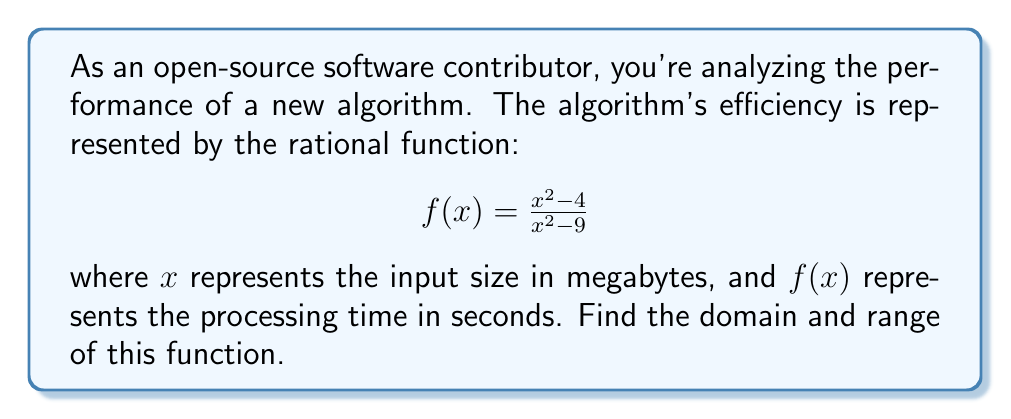Provide a solution to this math problem. To find the domain and range of this rational function, we'll follow these steps:

1. Domain:
   The domain consists of all real numbers except those that make the denominator zero.
   Set the denominator equal to zero and solve:
   $$x^2 - 9 = 0$$
   $$(x+3)(x-3) = 0$$
   $$x = \pm 3$$
   
   Therefore, the domain is all real numbers except $\pm 3$.

2. Range:
   To find the range, we'll rewrite the function in the form $y = f(x)$:
   $$y = \frac{x^2 - 4}{x^2 - 9}$$

   Multiply both sides by $(x^2 - 9)$:
   $$y(x^2 - 9) = x^2 - 4$$

   Expand:
   $$yx^2 - 9y = x^2 - 4$$

   Rearrange to group $x^2$ terms:
   $$x^2(y - 1) = 9y - 4$$

   $$x^2 = \frac{9y - 4}{y - 1}$$

   For this to be true, we need $y \neq 1$ (otherwise, we'd be dividing by zero).

   Now, since $x^2$ is always non-negative for real $x$, we must have:

   $$\frac{9y - 4}{y - 1} \geq 0$$

   This inequality is true when $y < 1$ or $y > \frac{4}{9}$.

   Combining these conditions, we get the range: $y \in (-\infty, \frac{4}{9}) \cup (1, \infty)$

3. Interpretation:
   - The domain excludes $\pm 3$ because these input sizes would cause a division by zero in the function.
   - The range indicates that the processing time can be any positive number except those between $\frac{4}{9}$ and 1 second.
   - As an open-source contributor, you might note that this function suggests the algorithm has a performance bottleneck for input sizes around 3 MB, which could be an area for optimization.
Answer: Domain: $x \in (-\infty, -3) \cup (-3, 3) \cup (3, \infty)$
Range: $y \in (-\infty, \frac{4}{9}) \cup (1, \infty)$ 